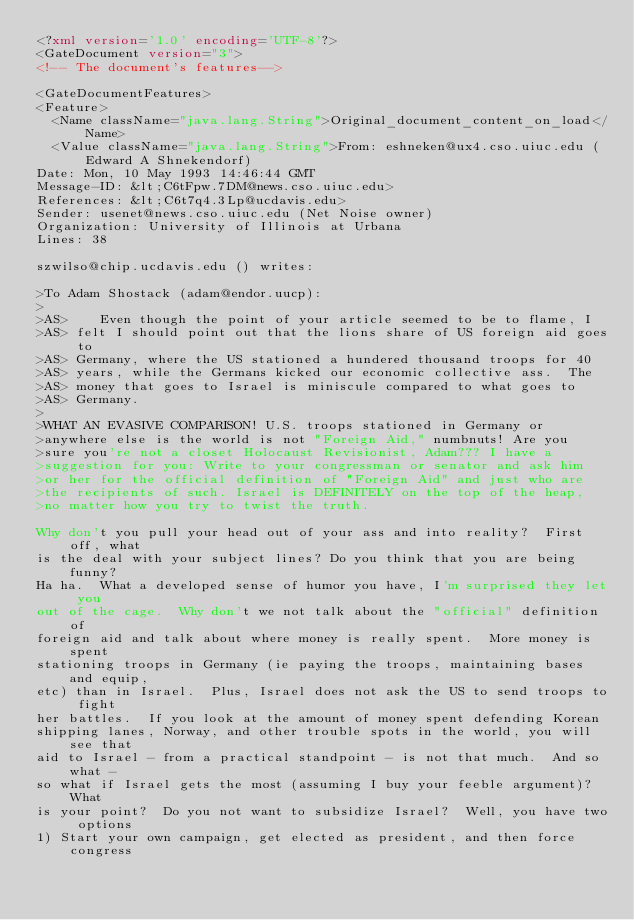Convert code to text. <code><loc_0><loc_0><loc_500><loc_500><_XML_><?xml version='1.0' encoding='UTF-8'?>
<GateDocument version="3">
<!-- The document's features-->

<GateDocumentFeatures>
<Feature>
  <Name className="java.lang.String">Original_document_content_on_load</Name>
  <Value className="java.lang.String">From: eshneken@ux4.cso.uiuc.edu (Edward A Shnekendorf)
Date: Mon, 10 May 1993 14:46:44 GMT
Message-ID: &lt;C6tFpw.7DM@news.cso.uiuc.edu>
References: &lt;C6t7q4.3Lp@ucdavis.edu>
Sender: usenet@news.cso.uiuc.edu (Net Noise owner)
Organization: University of Illinois at Urbana
Lines: 38

szwilso@chip.ucdavis.edu () writes:

>To Adam Shostack (adam@endor.uucp):
> 
>AS>	Even though the point of your article seemed to be to flame, I
>AS> felt I should point out that the lions share of US foreign aid goes to
>AS> Germany, where the US stationed a hundered thousand troops for 40
>AS> years, while the Germans kicked our economic collective ass.  The
>AS> money that goes to Israel is miniscule compared to what goes to
>AS> Germany.
> 
>WHAT AN EVASIVE COMPARISON! U.S. troops stationed in Germany or
>anywhere else is the world is not "Foreign Aid," numbnuts! Are you
>sure you're not a closet Holocaust Revisionist, Adam??? I have a
>suggestion for you: Write to your congressman or senator and ask him
>or her for the official definition of "Foreign Aid" and just who are
>the recipients of such. Israel is DEFINITELY on the top of the heap,
>no matter how you try to twist the truth.

Why don't you pull your head out of your ass and into reality?  First off, what
is the deal with your subject lines? Do you think that you are being funny?
Ha ha.  What a developed sense of humor you have, I'm surprised they let you 
out of the cage.  Why don't we not talk about the "official" definition of
foreign aid and talk about where money is really spent.  More money is spent
stationing troops in Germany (ie paying the troops, maintaining bases and equip,
etc) than in Israel.  Plus, Israel does not ask the US to send troops to fight
her battles.  If you look at the amount of money spent defending Korean 
shipping lanes, Norway, and other trouble spots in the world, you will see that
aid to Israel - from a practical standpoint - is not that much.  And so what -
so what if Israel gets the most (assuming I buy your feeble argument)?  What 
is your point?  Do you not want to subsidize Israel?  Well, you have two options
1) Start your own campaign, get elected as president, and then force congress</code> 